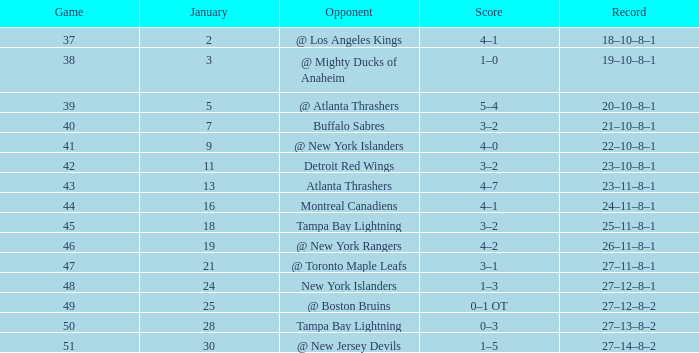How many Points have a January of 18? 1.0. 